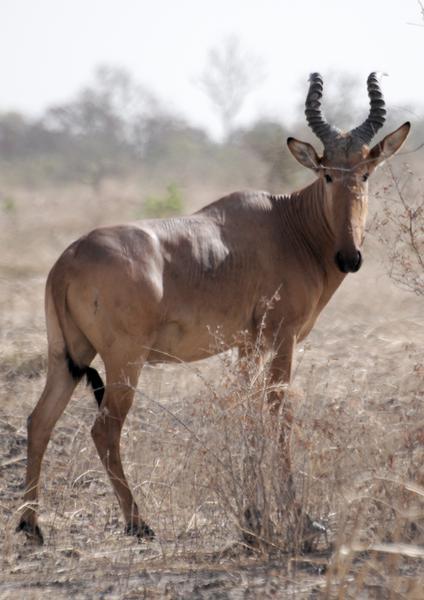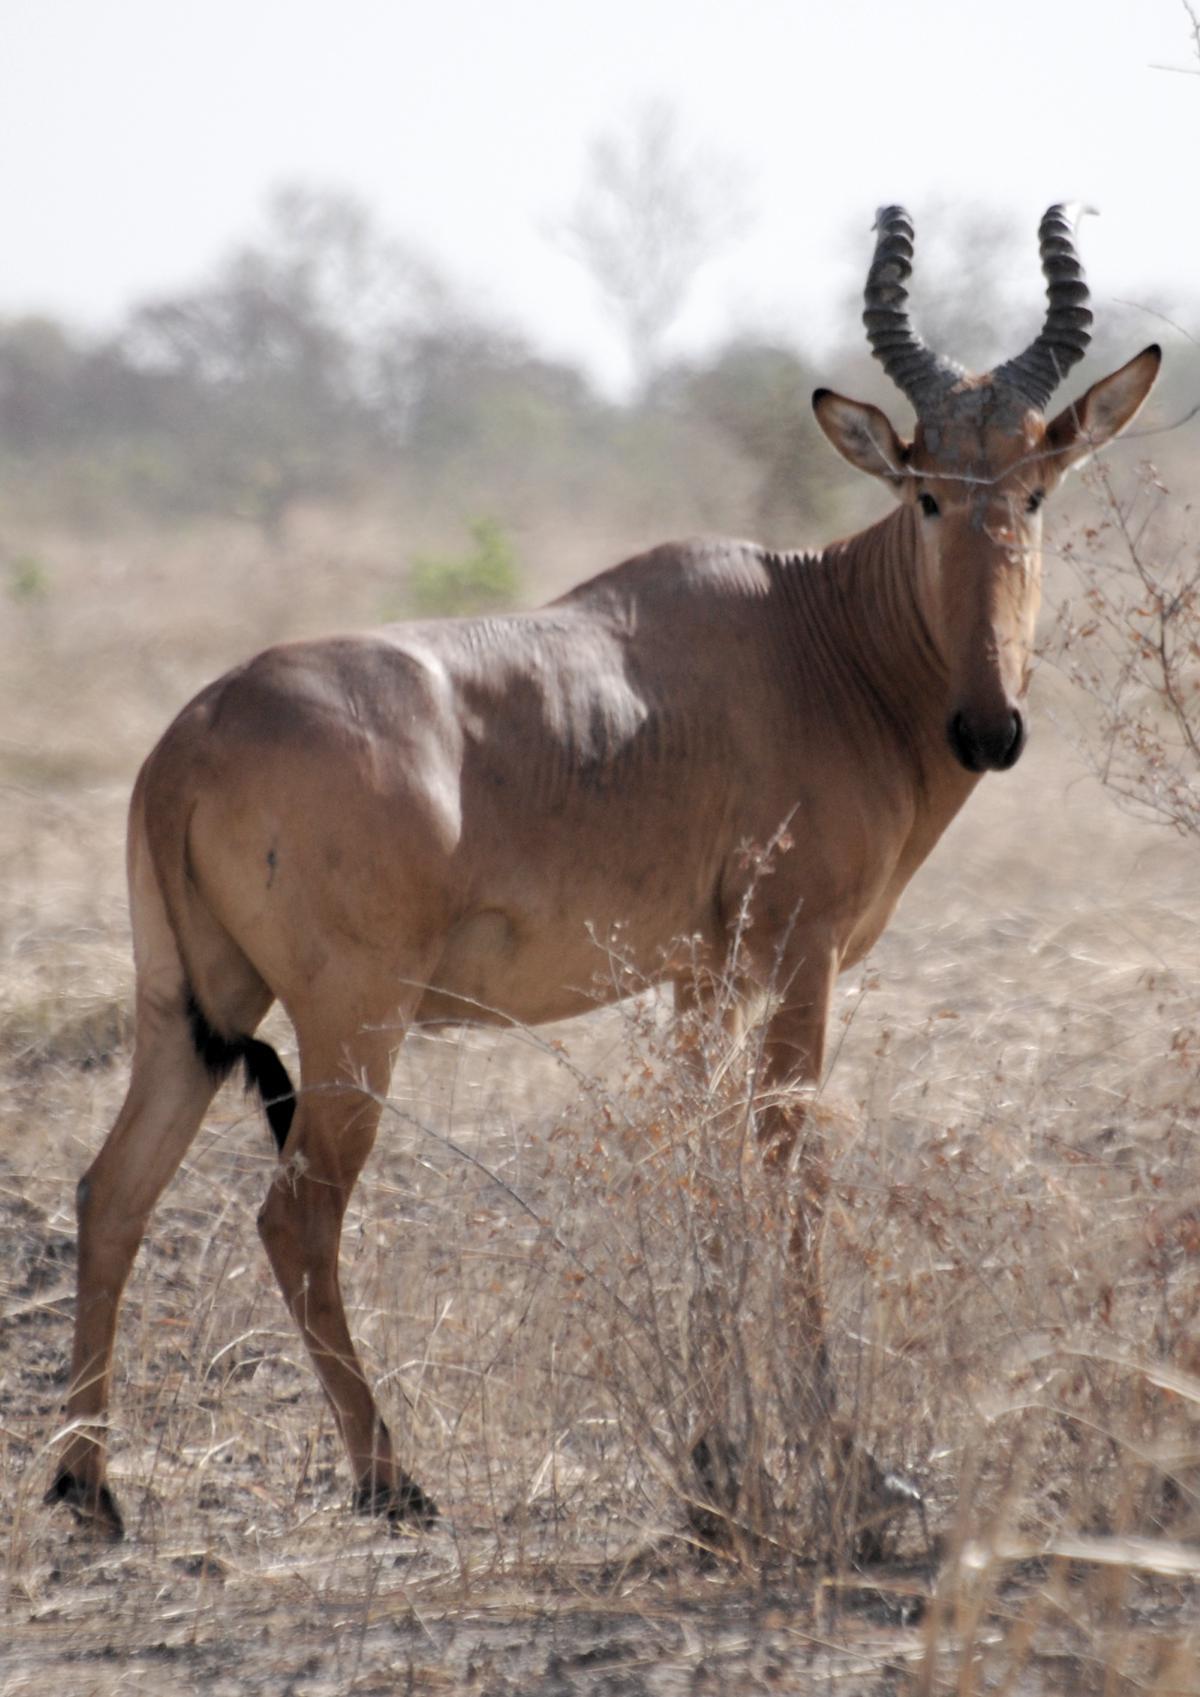The first image is the image on the left, the second image is the image on the right. Evaluate the accuracy of this statement regarding the images: "there are 3 antelope in the image pair". Is it true? Answer yes or no. No. 